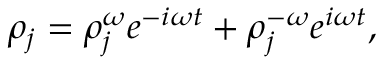Convert formula to latex. <formula><loc_0><loc_0><loc_500><loc_500>{ \rho } _ { j } = { \rho } _ { j } ^ { \omega } e ^ { - i \omega t } + { \rho } _ { j } ^ { - \omega } e ^ { i \omega t } ,</formula> 